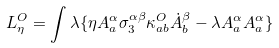Convert formula to latex. <formula><loc_0><loc_0><loc_500><loc_500>L _ { \eta } ^ { O } = \int \lambda \{ \eta A _ { a } ^ { \alpha } \sigma _ { 3 } ^ { \alpha \beta } \kappa _ { a b } ^ { O } \dot { A } _ { b } ^ { \beta } - \lambda A _ { a } ^ { \alpha } A _ { a } ^ { \alpha } \}</formula> 